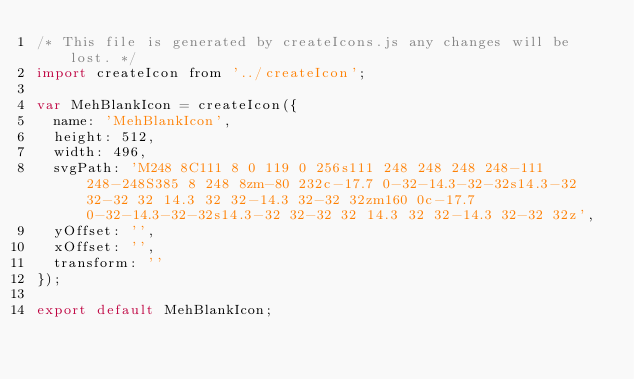Convert code to text. <code><loc_0><loc_0><loc_500><loc_500><_JavaScript_>/* This file is generated by createIcons.js any changes will be lost. */
import createIcon from '../createIcon';

var MehBlankIcon = createIcon({
  name: 'MehBlankIcon',
  height: 512,
  width: 496,
  svgPath: 'M248 8C111 8 0 119 0 256s111 248 248 248 248-111 248-248S385 8 248 8zm-80 232c-17.7 0-32-14.3-32-32s14.3-32 32-32 32 14.3 32 32-14.3 32-32 32zm160 0c-17.7 0-32-14.3-32-32s14.3-32 32-32 32 14.3 32 32-14.3 32-32 32z',
  yOffset: '',
  xOffset: '',
  transform: ''
});

export default MehBlankIcon;</code> 